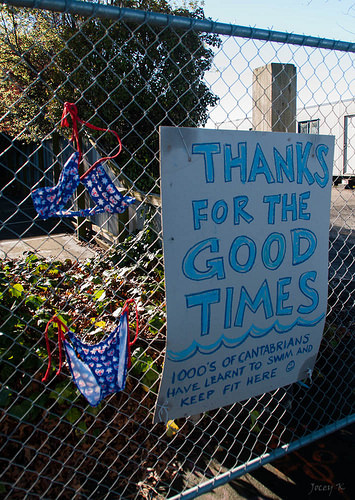<image>
Is there a fence in front of the sign? No. The fence is not in front of the sign. The spatial positioning shows a different relationship between these objects. 